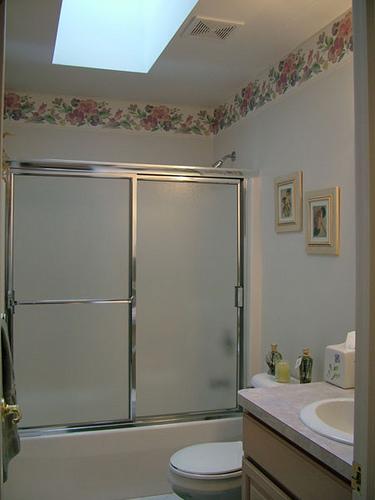What room is this?
Concise answer only. Bathroom. What is on the wall?
Be succinct. Pictures. Is the sidewall a full wall?
Short answer required. Yes. What style of painted art is hanging above the toilet?
Quick response, please. Flowers. Do you see a box of tissues?
Quick response, please. Yes. Would this room be used to bathe oneself?
Write a very short answer. Yes. How many sinks are there?
Be succinct. 1. Is this a modern  bathroom?
Quick response, please. Yes. Is it likely the photographer was impressed by the beauty and cleanliness of the room?
Give a very brief answer. Yes. Is this a hotel bathroom?
Be succinct. No. How would you describe the ceiling light?
Short answer required. Fluorescent. How large is the bathtub in the bathroom?
Write a very short answer. Large. Is this a kitchen?
Short answer required. No. How many windows are in the bathroom?
Concise answer only. 0. What shape is the bathtub?
Quick response, please. Rectangle. How many sinks do you see?
Give a very brief answer. 1. What color is the tub?
Concise answer only. White. Is there a decorative floral border at the top of the wall?
Concise answer only. Yes. Is the sink empty?
Quick response, please. Yes. What is on the wall above the bathtub?
Be succinct. Wallpaper border. Is this a luxury bathroom?
Answer briefly. No. What color is the shower door?
Quick response, please. Clear. Is the shower door open?
Short answer required. No. 